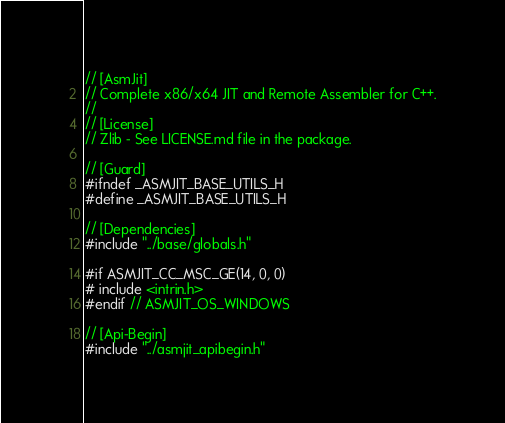<code> <loc_0><loc_0><loc_500><loc_500><_C_>// [AsmJit]
// Complete x86/x64 JIT and Remote Assembler for C++.
//
// [License]
// Zlib - See LICENSE.md file in the package.

// [Guard]
#ifndef _ASMJIT_BASE_UTILS_H
#define _ASMJIT_BASE_UTILS_H

// [Dependencies]
#include "../base/globals.h"

#if ASMJIT_CC_MSC_GE(14, 0, 0)
# include <intrin.h>
#endif // ASMJIT_OS_WINDOWS

// [Api-Begin]
#include "../asmjit_apibegin.h"
</code> 